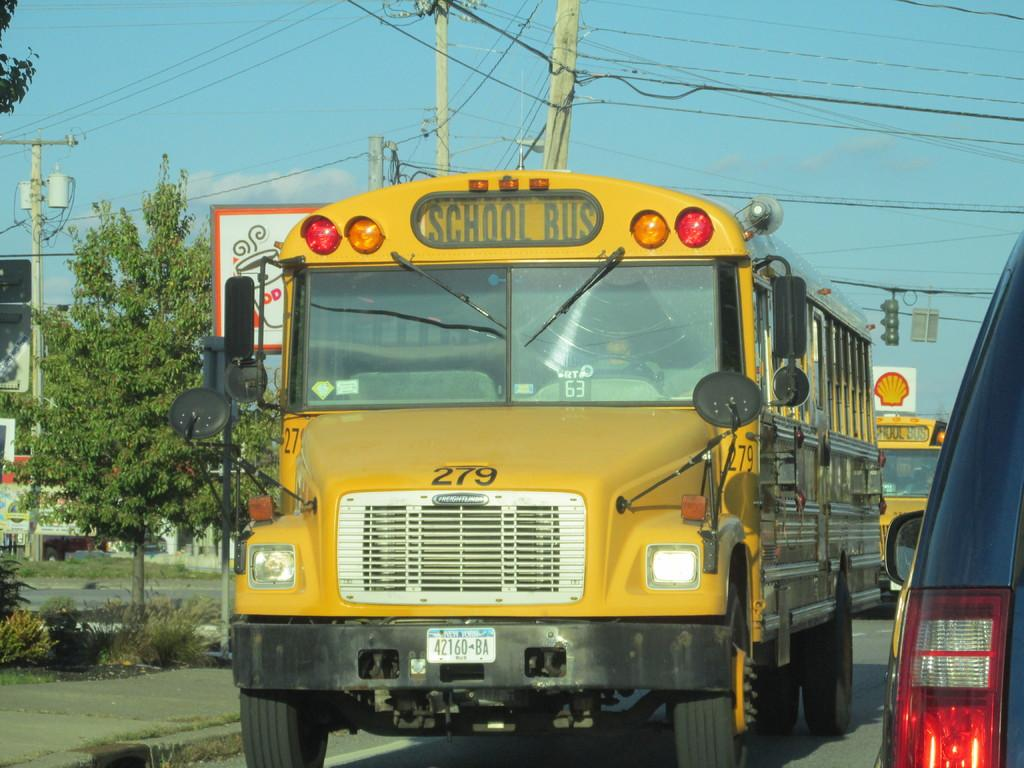What can be seen on the road in the image? There are vehicles on the road in the image. What type of natural elements are visible in the background of the image? There are trees in the background of the image. What type of man-made structures can be seen in the background of the image? There are poles in the background of the image. What part of the natural environment is visible in the image? The sky is visible in the background of the image. What type of furniture can be seen in the image? There is no furniture present in the image; it features vehicles on the road and natural elements in the background. What color is the paint on the trees in the image? The image does not provide information about the color of the paint on the trees, as it does not mention any paint on the trees. 